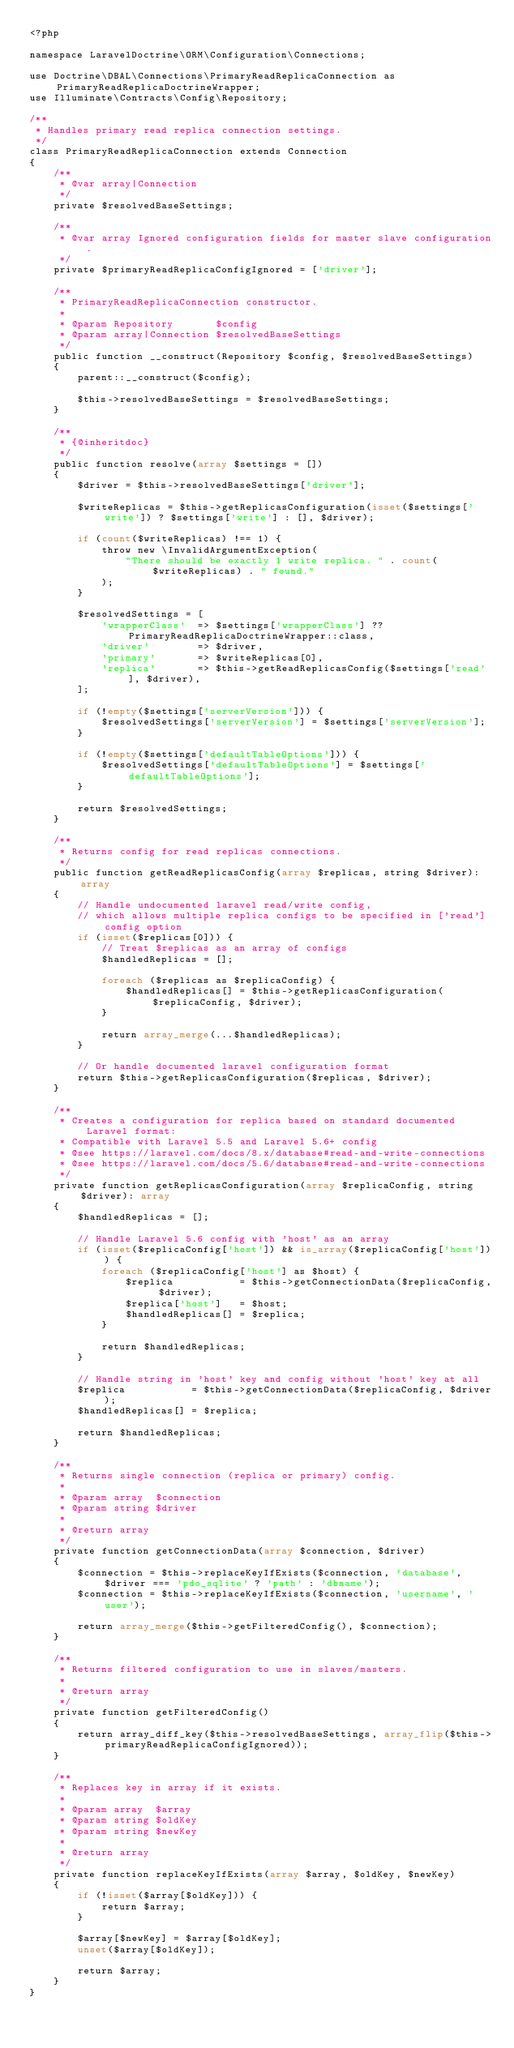Convert code to text. <code><loc_0><loc_0><loc_500><loc_500><_PHP_><?php

namespace LaravelDoctrine\ORM\Configuration\Connections;

use Doctrine\DBAL\Connections\PrimaryReadReplicaConnection as PrimaryReadReplicaDoctrineWrapper;
use Illuminate\Contracts\Config\Repository;

/**
 * Handles primary read replica connection settings.
 */
class PrimaryReadReplicaConnection extends Connection
{
    /**
     * @var array|Connection
     */
    private $resolvedBaseSettings;

    /**
     * @var array Ignored configuration fields for master slave configuration.
     */
    private $primaryReadReplicaConfigIgnored = ['driver'];

    /**
     * PrimaryReadReplicaConnection constructor.
     *
     * @param Repository       $config
     * @param array|Connection $resolvedBaseSettings
     */
    public function __construct(Repository $config, $resolvedBaseSettings)
    {
        parent::__construct($config);

        $this->resolvedBaseSettings = $resolvedBaseSettings;
    }

    /**
     * {@inheritdoc}
     */
    public function resolve(array $settings = [])
    {
        $driver = $this->resolvedBaseSettings['driver'];

        $writeReplicas = $this->getReplicasConfiguration(isset($settings['write']) ? $settings['write'] : [], $driver);

        if (count($writeReplicas) !== 1) {
            throw new \InvalidArgumentException(
                "There should be exactly 1 write replica. " . count($writeReplicas) . " found."
            );
        }

        $resolvedSettings = [
            'wrapperClass'  => $settings['wrapperClass'] ?? PrimaryReadReplicaDoctrineWrapper::class,
            'driver'        => $driver,
            'primary'       => $writeReplicas[0],
            'replica'       => $this->getReadReplicasConfig($settings['read'], $driver),
        ];

        if (!empty($settings['serverVersion'])) {
            $resolvedSettings['serverVersion'] = $settings['serverVersion'];
        }

        if (!empty($settings['defaultTableOptions'])) {
            $resolvedSettings['defaultTableOptions'] = $settings['defaultTableOptions'];
        }

        return $resolvedSettings;
    }

    /**
     * Returns config for read replicas connections.
     */
    public function getReadReplicasConfig(array $replicas, string $driver): array
    {
        // Handle undocumented laravel read/write config,
        // which allows multiple replica configs to be specified in ['read'] config option
        if (isset($replicas[0])) {
            // Treat $replicas as an array of configs
            $handledReplicas = [];

            foreach ($replicas as $replicaConfig) {
                $handledReplicas[] = $this->getReplicasConfiguration($replicaConfig, $driver);
            }

            return array_merge(...$handledReplicas);
        }

        // Or handle documented laravel configuration format
        return $this->getReplicasConfiguration($replicas, $driver);
    }

    /**
     * Creates a configuration for replica based on standard documented Laravel format:
     * Compatible with Laravel 5.5 and Laravel 5.6+ config
     * @see https://laravel.com/docs/8.x/database#read-and-write-connections
     * @see https://laravel.com/docs/5.6/database#read-and-write-connections
     */
    private function getReplicasConfiguration(array $replicaConfig, string $driver): array
    {
        $handledReplicas = [];

        // Handle Laravel 5.6 config with 'host' as an array
        if (isset($replicaConfig['host']) && is_array($replicaConfig['host'])) {
            foreach ($replicaConfig['host'] as $host) {
                $replica           = $this->getConnectionData($replicaConfig, $driver);
                $replica['host']   = $host;
                $handledReplicas[] = $replica;
            }

            return $handledReplicas;
        }

        // Handle string in 'host' key and config without 'host' key at all
        $replica           = $this->getConnectionData($replicaConfig, $driver);
        $handledReplicas[] = $replica;

        return $handledReplicas;
    }

    /**
     * Returns single connection (replica or primary) config.
     *
     * @param array  $connection
     * @param string $driver
     *
     * @return array
     */
    private function getConnectionData(array $connection, $driver)
    {
        $connection = $this->replaceKeyIfExists($connection, 'database', $driver === 'pdo_sqlite' ? 'path' : 'dbname');
        $connection = $this->replaceKeyIfExists($connection, 'username', 'user');

        return array_merge($this->getFilteredConfig(), $connection);
    }

    /**
     * Returns filtered configuration to use in slaves/masters.
     *
     * @return array
     */
    private function getFilteredConfig()
    {
        return array_diff_key($this->resolvedBaseSettings, array_flip($this->primaryReadReplicaConfigIgnored));
    }

    /**
     * Replaces key in array if it exists.
     *
     * @param array  $array
     * @param string $oldKey
     * @param string $newKey
     *
     * @return array
     */
    private function replaceKeyIfExists(array $array, $oldKey, $newKey)
    {
        if (!isset($array[$oldKey])) {
            return $array;
        }

        $array[$newKey] = $array[$oldKey];
        unset($array[$oldKey]);

        return $array;
    }
}
</code> 